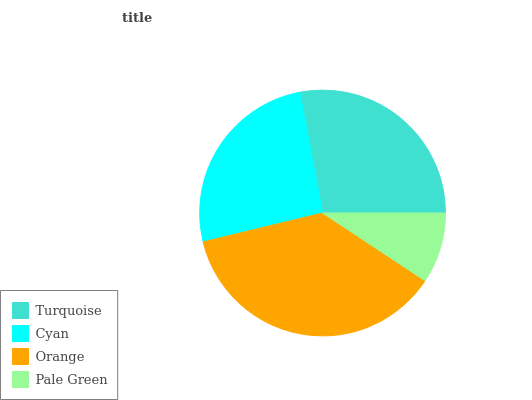Is Pale Green the minimum?
Answer yes or no. Yes. Is Orange the maximum?
Answer yes or no. Yes. Is Cyan the minimum?
Answer yes or no. No. Is Cyan the maximum?
Answer yes or no. No. Is Turquoise greater than Cyan?
Answer yes or no. Yes. Is Cyan less than Turquoise?
Answer yes or no. Yes. Is Cyan greater than Turquoise?
Answer yes or no. No. Is Turquoise less than Cyan?
Answer yes or no. No. Is Turquoise the high median?
Answer yes or no. Yes. Is Cyan the low median?
Answer yes or no. Yes. Is Pale Green the high median?
Answer yes or no. No. Is Turquoise the low median?
Answer yes or no. No. 